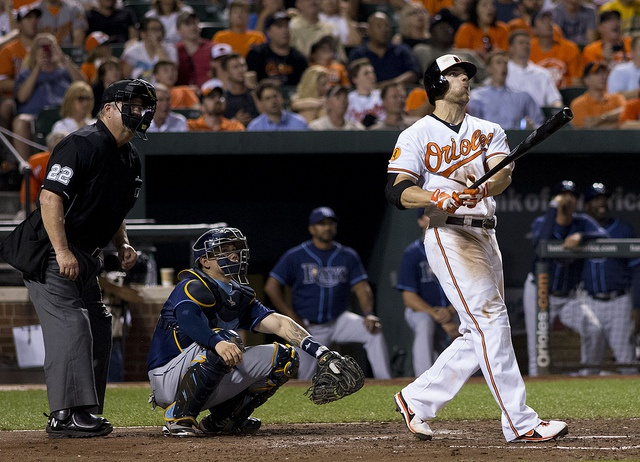Describe the objects in this image and their specific colors. I can see people in maroon, black, and gray tones, people in maroon, lavender, black, darkgray, and gray tones, people in maroon, black, gray, and tan tones, people in maroon, black, gray, darkgray, and navy tones, and people in maroon, black, gray, and navy tones in this image. 